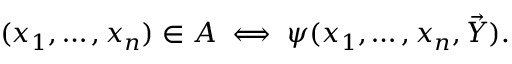Convert formula to latex. <formula><loc_0><loc_0><loc_500><loc_500>( x _ { 1 } , \dots , x _ { n } ) \in A \iff \psi ( x _ { 1 } , \dots , x _ { n } , { \vec { Y } } ) .</formula> 